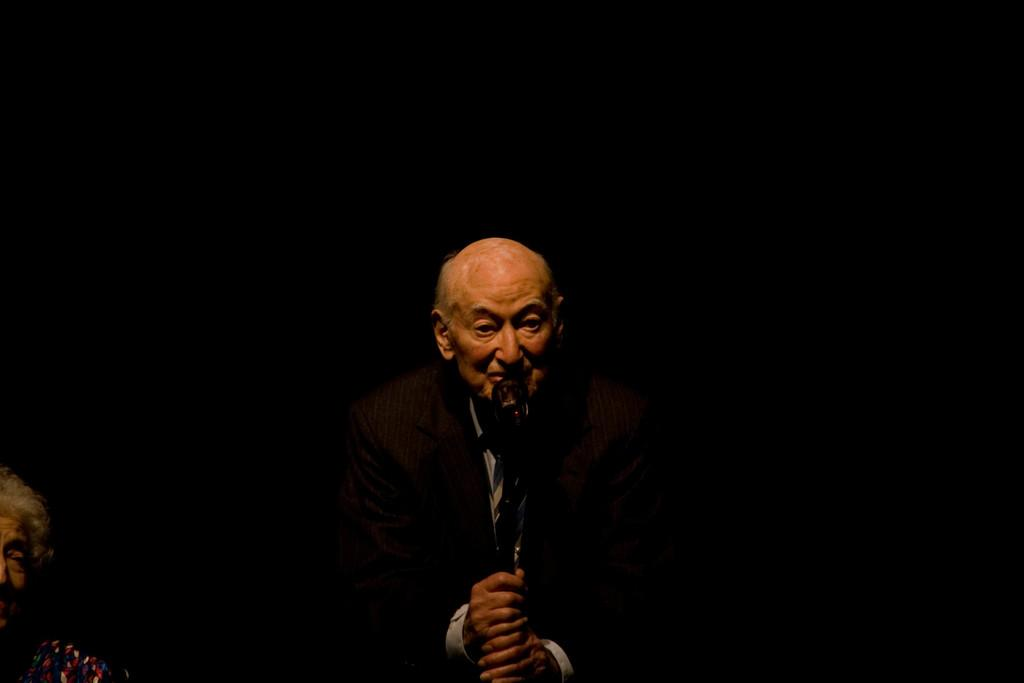Who is the main subject in the image? There is an old man in the image. What is the old man holding in the image? The old man is holding a microphone. Can you describe the woman in the image? There is an old woman on the left side of the image. What is the color of the background in the image? The background of the image is black. How far away is the pig from the old man in the image? There is no pig present in the image, so it is not possible to determine the distance between the old man and a pig. 